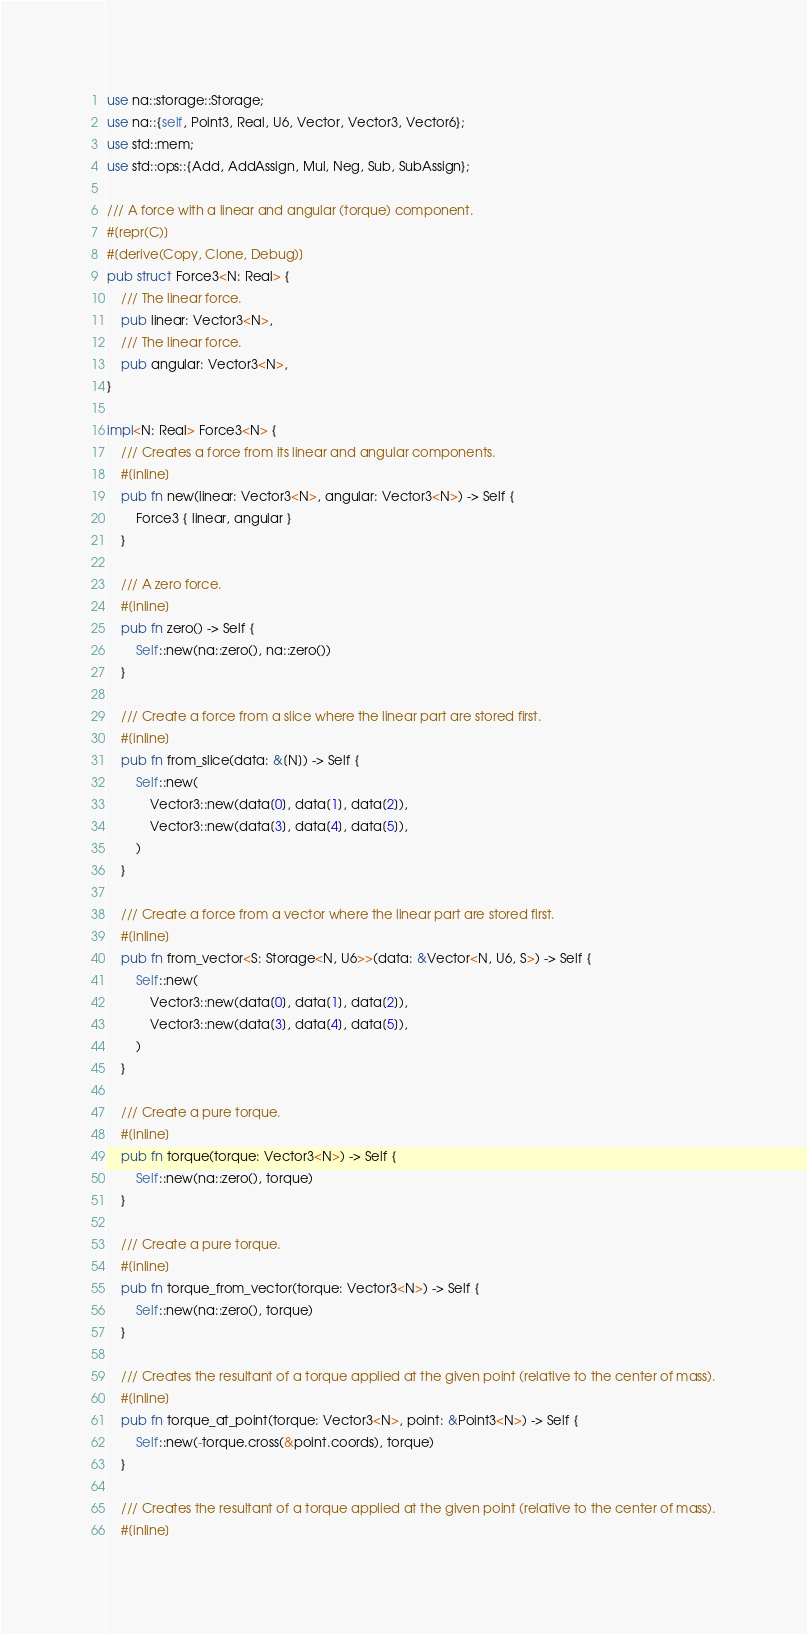Convert code to text. <code><loc_0><loc_0><loc_500><loc_500><_Rust_>use na::storage::Storage;
use na::{self, Point3, Real, U6, Vector, Vector3, Vector6};
use std::mem;
use std::ops::{Add, AddAssign, Mul, Neg, Sub, SubAssign};

/// A force with a linear and angular (torque) component.
#[repr(C)]
#[derive(Copy, Clone, Debug)]
pub struct Force3<N: Real> {
    /// The linear force.
    pub linear: Vector3<N>,
    /// The linear force.
    pub angular: Vector3<N>,
}

impl<N: Real> Force3<N> {
    /// Creates a force from its linear and angular components.
    #[inline]
    pub fn new(linear: Vector3<N>, angular: Vector3<N>) -> Self {
        Force3 { linear, angular }
    }

    /// A zero force.
    #[inline]
    pub fn zero() -> Self {
        Self::new(na::zero(), na::zero())
    }

    /// Create a force from a slice where the linear part are stored first.
    #[inline]
    pub fn from_slice(data: &[N]) -> Self {
        Self::new(
            Vector3::new(data[0], data[1], data[2]),
            Vector3::new(data[3], data[4], data[5]),
        )
    }

    /// Create a force from a vector where the linear part are stored first.
    #[inline]
    pub fn from_vector<S: Storage<N, U6>>(data: &Vector<N, U6, S>) -> Self {
        Self::new(
            Vector3::new(data[0], data[1], data[2]),
            Vector3::new(data[3], data[4], data[5]),
        )
    }

    /// Create a pure torque.
    #[inline]
    pub fn torque(torque: Vector3<N>) -> Self {
        Self::new(na::zero(), torque)
    }

    /// Create a pure torque.
    #[inline]
    pub fn torque_from_vector(torque: Vector3<N>) -> Self {
        Self::new(na::zero(), torque)
    }

    /// Creates the resultant of a torque applied at the given point (relative to the center of mass).
    #[inline]
    pub fn torque_at_point(torque: Vector3<N>, point: &Point3<N>) -> Self {
        Self::new(-torque.cross(&point.coords), torque)
    }

    /// Creates the resultant of a torque applied at the given point (relative to the center of mass).
    #[inline]</code> 